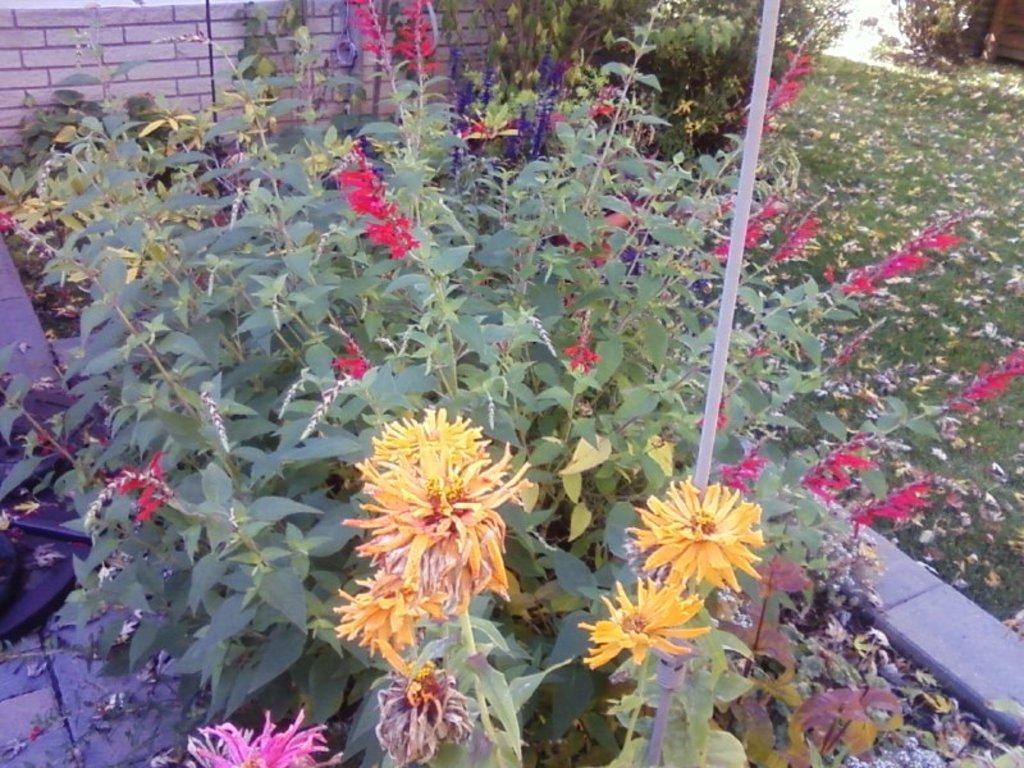Could you give a brief overview of what you see in this image? In this picture I can see there are few plants and they have different colors of flowers like red, blue, yellow. There is a wall in the backdrop and there is a plant, on to right there is grass on the floor and there are dry leaves on the grass. 